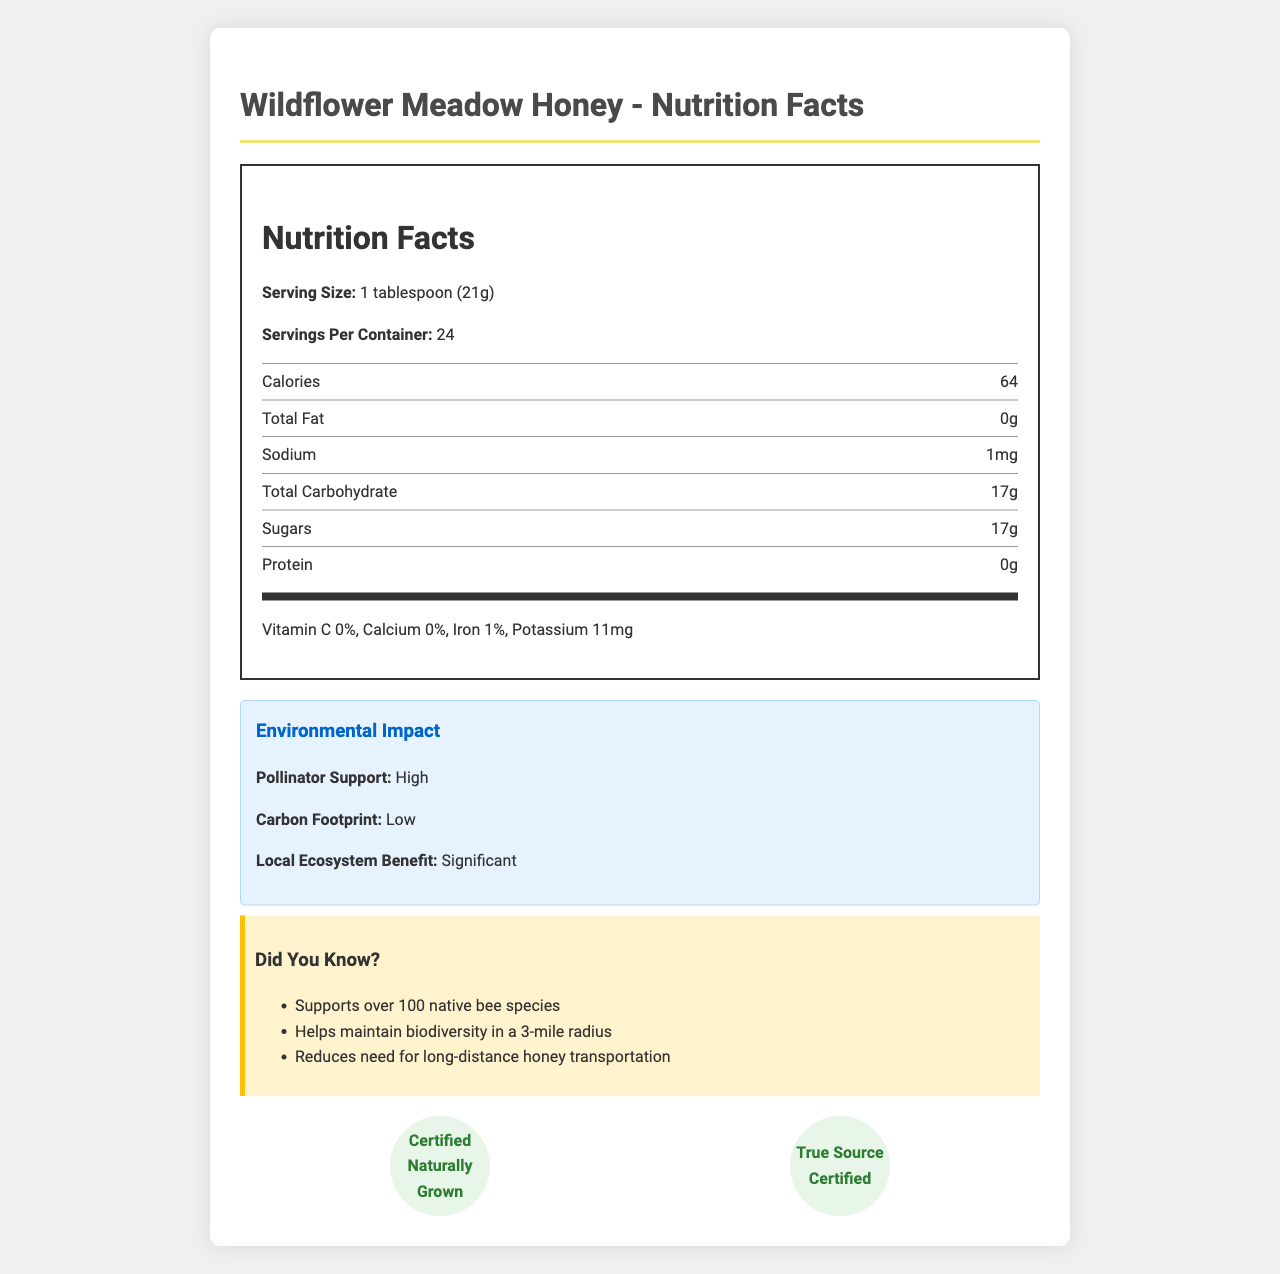what is the serving size of Wildflower Meadow Honey? The document specifies the serving size as "1 tablespoon (21g)".
Answer: 1 tablespoon (21g) how many calories are in one serving of Wildflower Meadow Honey? According to the Nutrition Facts, each serving contains 64 calories.
Answer: 64 what area benefits from the local ecosystem efforts supported by this honey? The document states that the apiary is located in the Blue Ridge Mountains, Virginia, and this is the area benefiting from the ecosystem efforts.
Answer: Blue Ridge Mountains, Virginia which flower sources are used for Wildflower Meadow Honey? The document lists these flowers under the "flowerSources" section.
Answer: Goldenrod, Aster, Clover, Thistle, Wild Raspberry what certifications does Wildflower Meadow Honey have? The document mentions these two certifications in the section detailing certifications.
Answer: Certified Naturally Grown, True Source Certified what percentage of iron does one serving of Wildflower Meadow Honey provide? Iron content per serving is listed as 1% in the Nutrition Facts.
Answer: 1% which harvesting season is Wildflower Meadow Honey associated with? The document specifies that this honey is harvested in the summer.
Answer: Summer Harvest what is the environmental impact of consuming Wildflower Meadow Honey? The environmental impact section of the document details these benefits.
Answer: High pollinator support, Low carbon footprint, Significant local ecosystem benefit what beekeeping practices are used by Beeline Apiaries? A. Conventional B. Non-Migratory C. Organic D. Intensive The document states that Beeline Apiaries uses "Sustainable, Non-Migratory" beekeeping practices.
Answer: B how many servings are in one container of Wildflower Meadow Honey? The document lists 24 servings per container.
Answer: 24 what are some nutritional benefits of Wildflower Meadow Honey? (Choose all that apply) I. Natural energy source II. Rich in Vitamin C III. Contains antioxidants IV. May have antimicrobial properties The nutritional benefits section lists "Natural energy source," "Contains antioxidants," and "May have antimicrobial properties," while Vitamin C is not mentioned as a benefit.
Answer: I, III, IV does Wildflower Meadow Honey contain sodium? The nutrition label shows that the honey contains 1mg of sodium per serving.
Answer: Yes what is the main idea of the document? The document includes sections on nutrition facts, environmental impact, and certifications, highlighting the honey's role in supporting pollinators and sustainability.
Answer: The document provides detailed nutritional information, environmental impact, and certifications for Wildflower Meadow Honey, emphasizing its benefits to pollinator populations and local ecosystems. what are the educational programs for local farmers? The document mentions that there are educational programs for local farmers but does not provide details about the programs.
Answer: Not enough information 